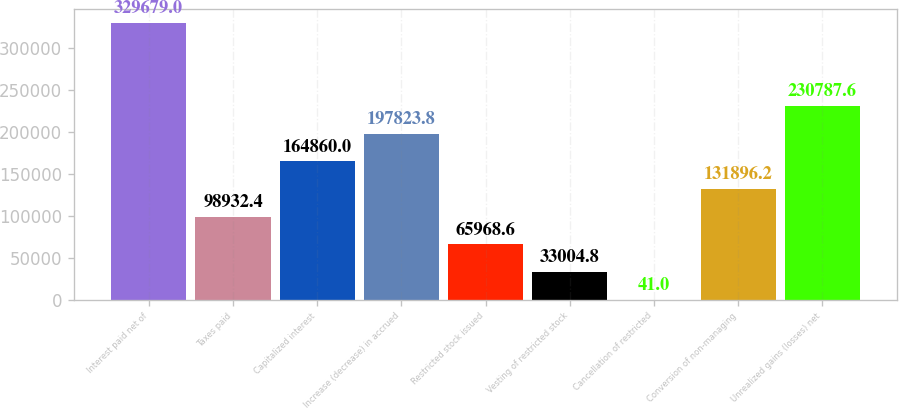Convert chart to OTSL. <chart><loc_0><loc_0><loc_500><loc_500><bar_chart><fcel>Interest paid net of<fcel>Taxes paid<fcel>Capitalized interest<fcel>Increase (decrease) in accrued<fcel>Restricted stock issued<fcel>Vesting of restricted stock<fcel>Cancellation of restricted<fcel>Conversion of non-managing<fcel>Unrealized gains (losses) net<nl><fcel>329679<fcel>98932.4<fcel>164860<fcel>197824<fcel>65968.6<fcel>33004.8<fcel>41<fcel>131896<fcel>230788<nl></chart> 